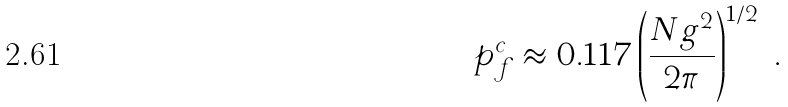Convert formula to latex. <formula><loc_0><loc_0><loc_500><loc_500>p _ { f } ^ { c } \approx 0 . 1 1 7 \left ( \frac { N g ^ { 2 } } { 2 \pi } \right ) ^ { 1 / 2 } \ .</formula> 